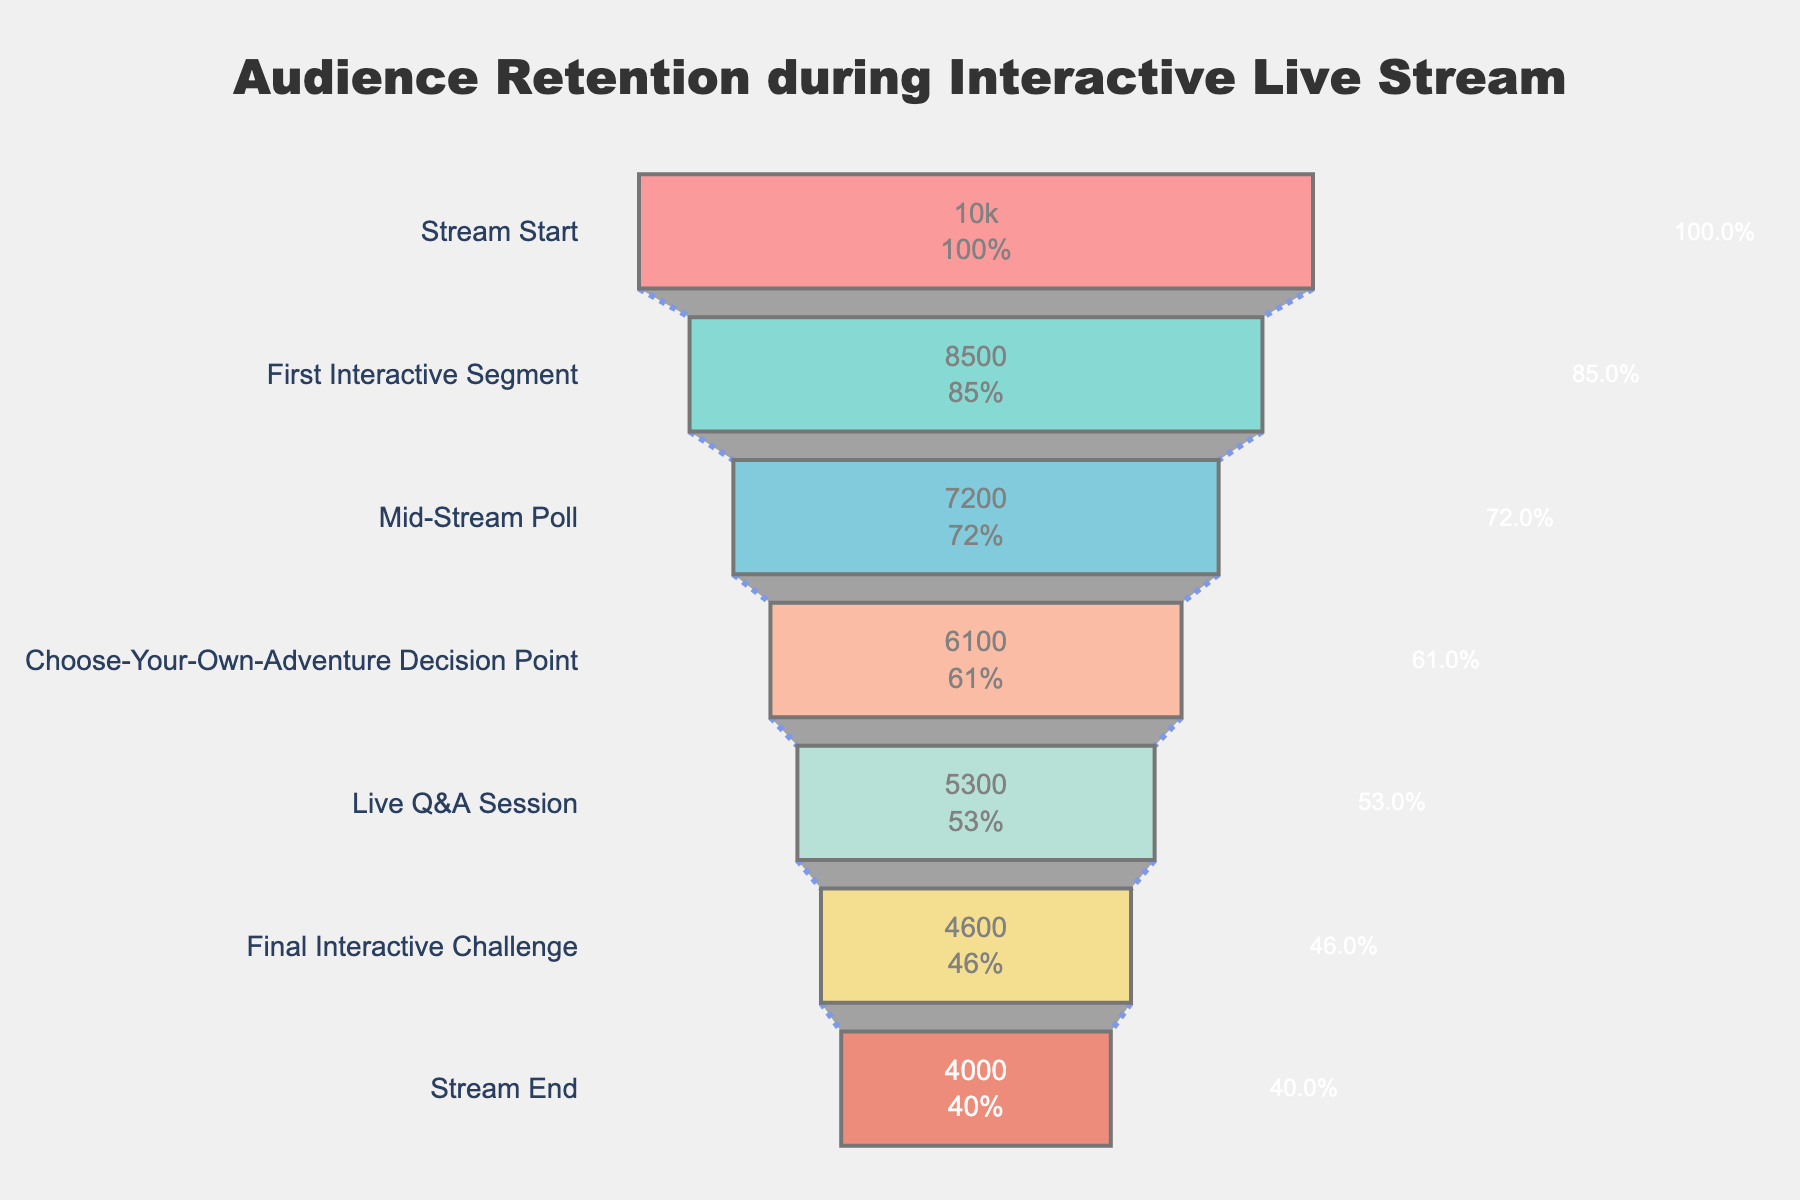What's the title of the plot? Look at the top of the figure to find the title. The title is typically displayed in a larger and bolder font.
Answer: Audience Retention during Interactive Live Stream How many stages are represented in the funnel chart? Count the number of stages labeled on the y-axis. These stages include "Stream Start," "First Interactive Segment," and so on. There are seven stages in total.
Answer: 7 Which stage has the highest number of viewers? Identify the stage with the longest bar on the chart. The bar's length represents the number of viewers. The "Stream Start" stage has the longest bar.
Answer: Stream Start What's the percentage drop-off from the "Stream Start" to the "Choose-Your-Own-Adventure Decision Point"? Calculate the difference in viewers between the "Stream Start" (10,000) and the "Choose-Your-Own-Adventure Decision Point" (6,100). Then, divide by the initial number of viewers and multiply by 100 to get the percentage: ((10,000 - 6,100) / 10,000) * 100 = 39%.
Answer: 39% Which stage has the lowest audience retention? Identify the stage with the shortest bar on the chart. The bar's length represents the number of viewers. The "Stream End" stage has the shortest bar.
Answer: Stream End How many viewers participated in the "Mid-Stream Poll"? Look at the bar corresponding to the "Mid-Stream Poll" stage, and read the number of viewers written inside the bar.
Answer: 7,200 What is the visual color of the "Live Q&A Session" bar? Observe the color of the bar corresponding to the "Live Q&A Session" stage.
Answer: Light Yellow (#F6D55C) What's the difference in the number of viewers between the "First Interactive Segment" and the "Stream End"? Subtract the number of viewers at the "Stream End" (4,000) from the number of viewers at the "First Interactive Segment" (8,500): 8,500 - 4,000 = 4,500.
Answer: 4,500 Which segment shows the most significant drop in viewers? Compare the difference in viewers between each consecutive stage. Identify the stage with the largest viewer drop using subtraction, which happens between "First Interactive Segment" (8,500) and "Mid-Stream Poll" (7,200), a drop of 1,300.
Answer: First Interactive Segment to Mid-Stream Poll What percentage of viewers stayed until the "Final Interactive Challenge"? Divide the number of viewers at the "Final Interactive Challenge" (4,600) by the initial number of viewers (10,000) and multiply by 100: (4,600 / 10,000) * 100 = 46%.
Answer: 46% 